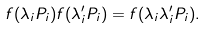<formula> <loc_0><loc_0><loc_500><loc_500>f ( \lambda _ { i } P _ { i } ) f ( \lambda ^ { \prime } _ { i } P _ { i } ) = f ( \lambda _ { i } \lambda ^ { \prime } _ { i } P _ { i } ) .</formula> 